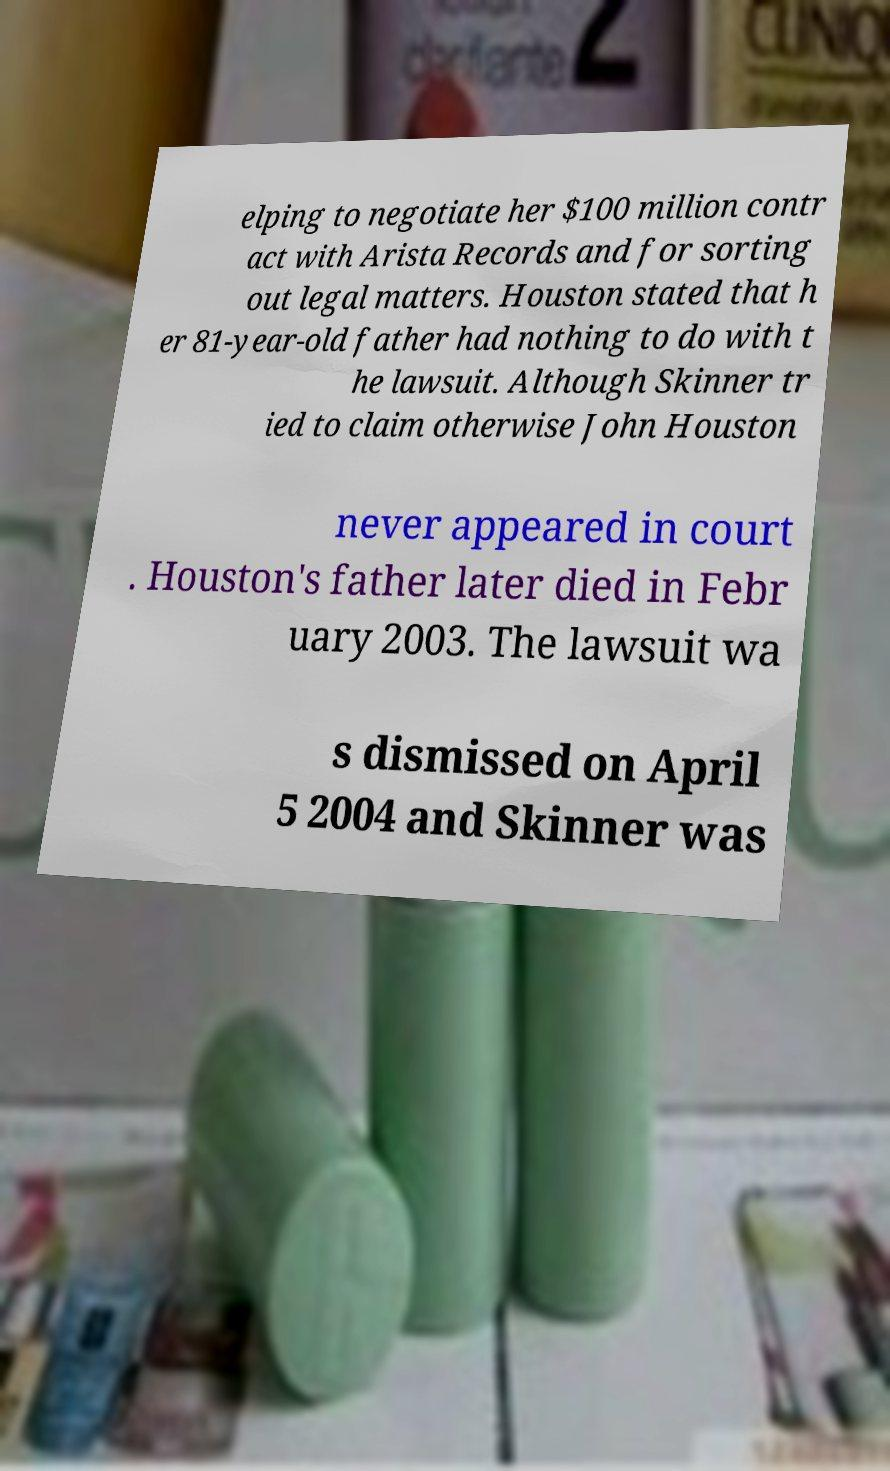For documentation purposes, I need the text within this image transcribed. Could you provide that? elping to negotiate her $100 million contr act with Arista Records and for sorting out legal matters. Houston stated that h er 81-year-old father had nothing to do with t he lawsuit. Although Skinner tr ied to claim otherwise John Houston never appeared in court . Houston's father later died in Febr uary 2003. The lawsuit wa s dismissed on April 5 2004 and Skinner was 